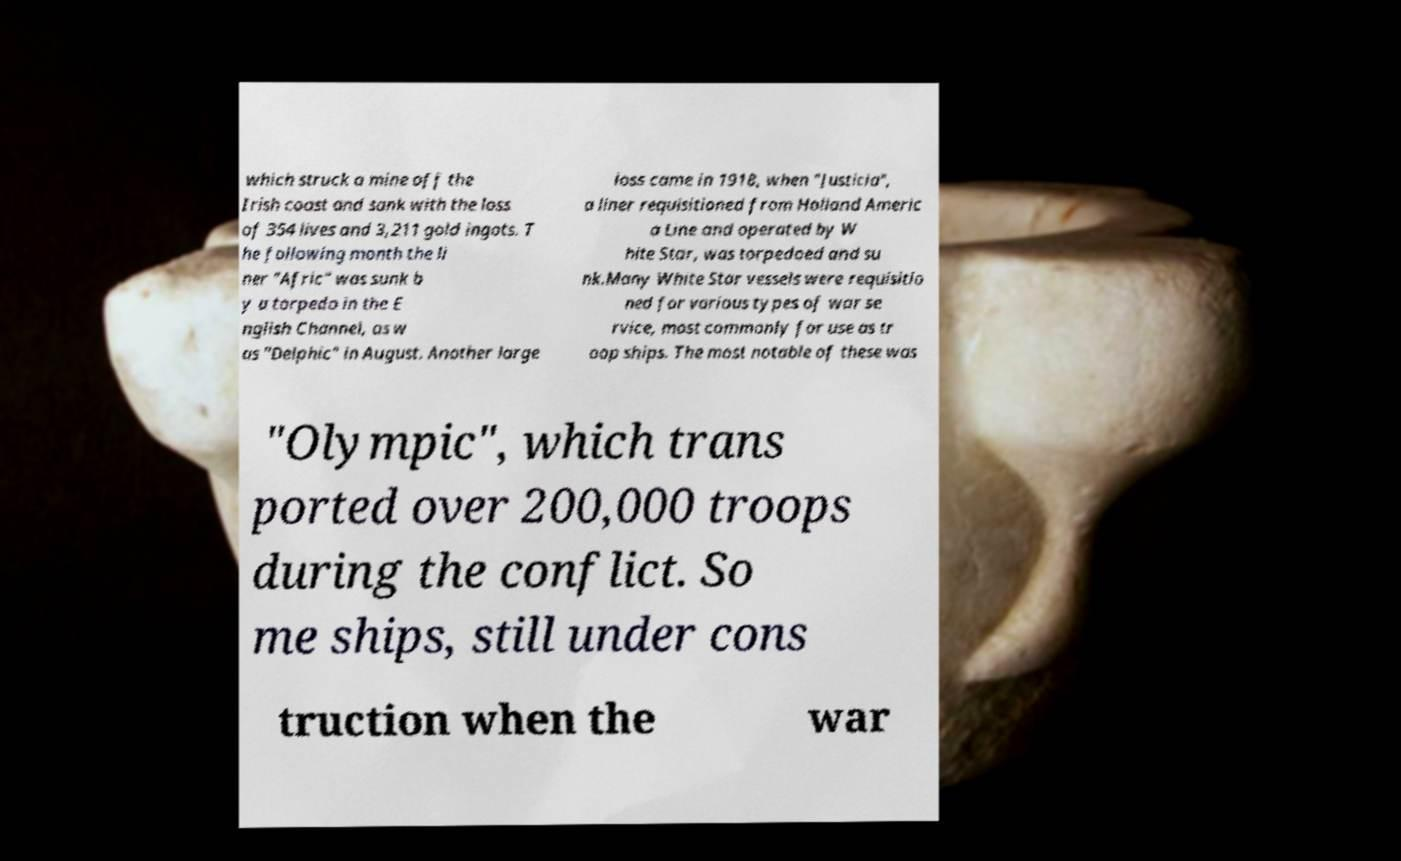Please read and relay the text visible in this image. What does it say? which struck a mine off the Irish coast and sank with the loss of 354 lives and 3,211 gold ingots. T he following month the li ner "Afric" was sunk b y a torpedo in the E nglish Channel, as w as "Delphic" in August. Another large loss came in 1918, when "Justicia", a liner requisitioned from Holland Americ a Line and operated by W hite Star, was torpedoed and su nk.Many White Star vessels were requisitio ned for various types of war se rvice, most commonly for use as tr oop ships. The most notable of these was "Olympic", which trans ported over 200,000 troops during the conflict. So me ships, still under cons truction when the war 